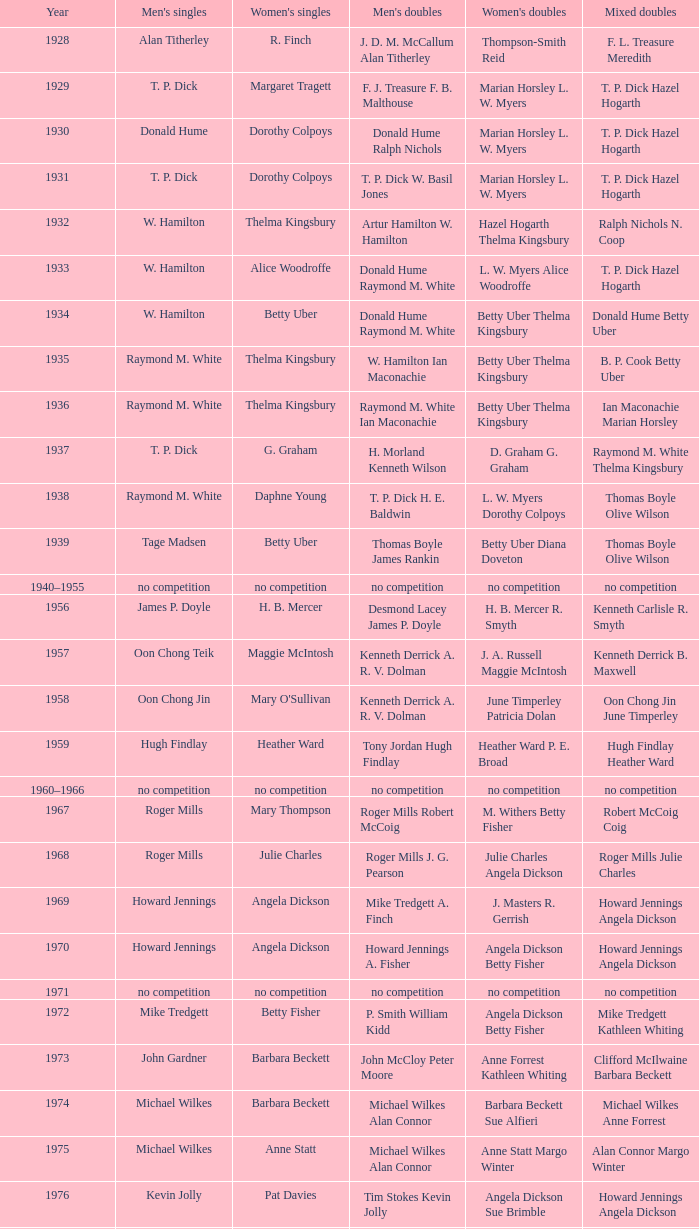Who was the men's singles champion in the year ian maconachie marian horsley secured the mixed doubles title? Raymond M. White. 